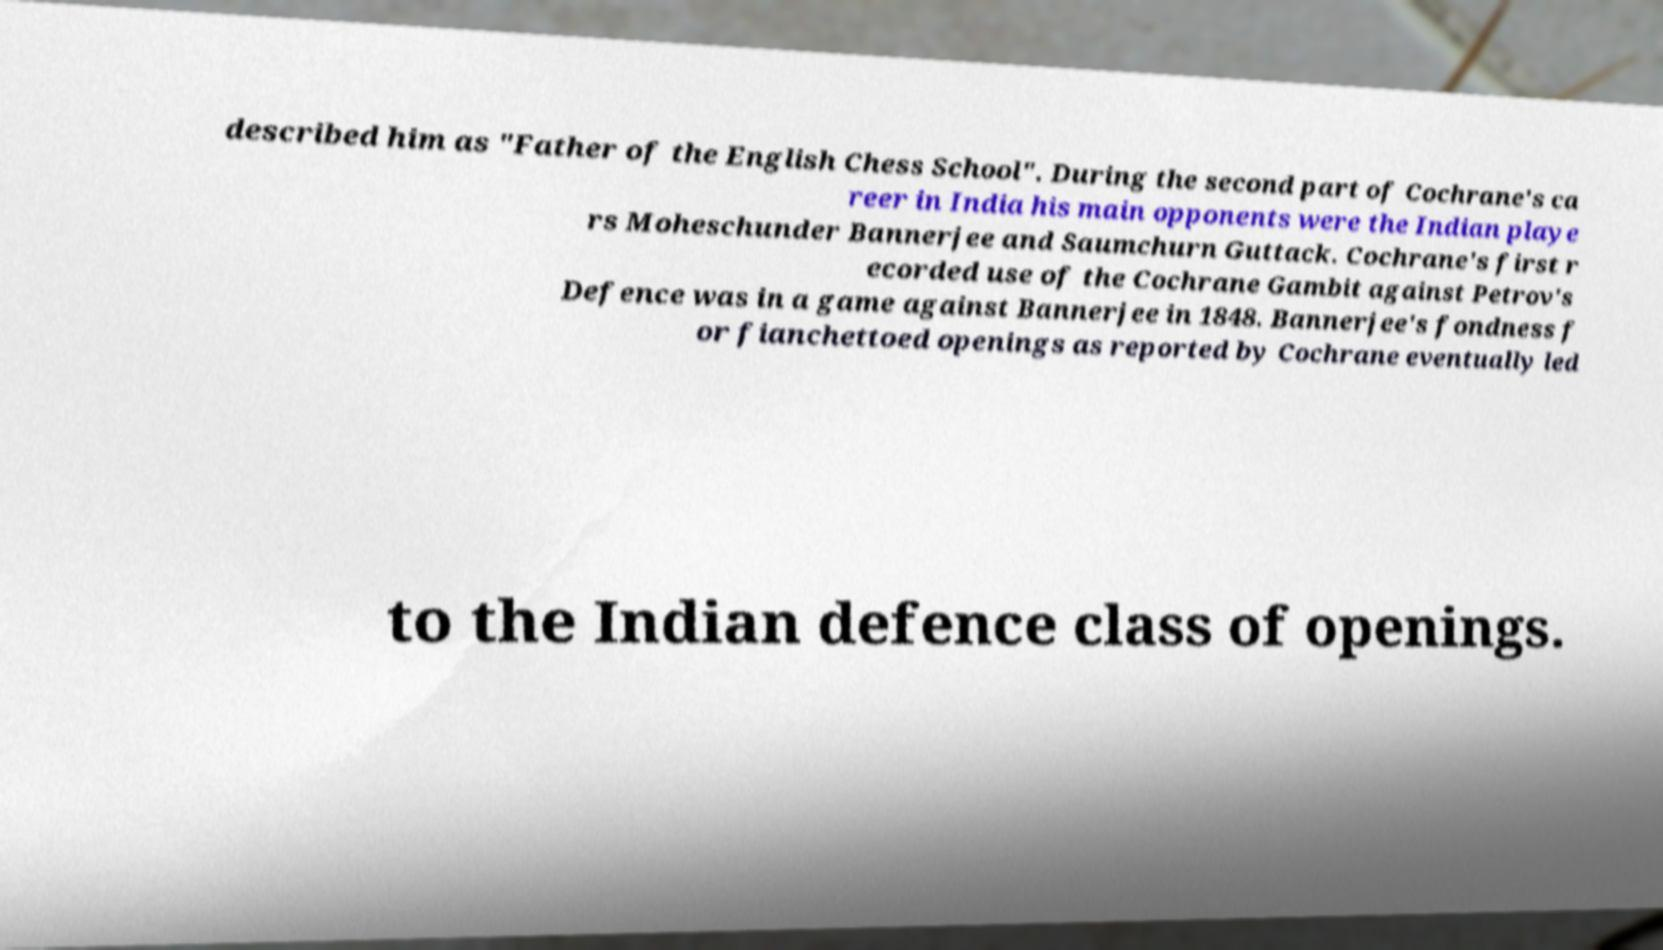Can you read and provide the text displayed in the image?This photo seems to have some interesting text. Can you extract and type it out for me? described him as "Father of the English Chess School". During the second part of Cochrane's ca reer in India his main opponents were the Indian playe rs Moheschunder Bannerjee and Saumchurn Guttack. Cochrane's first r ecorded use of the Cochrane Gambit against Petrov's Defence was in a game against Bannerjee in 1848. Bannerjee's fondness f or fianchettoed openings as reported by Cochrane eventually led to the Indian defence class of openings. 